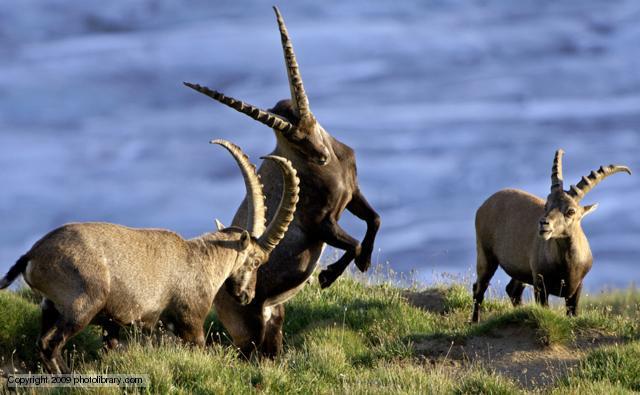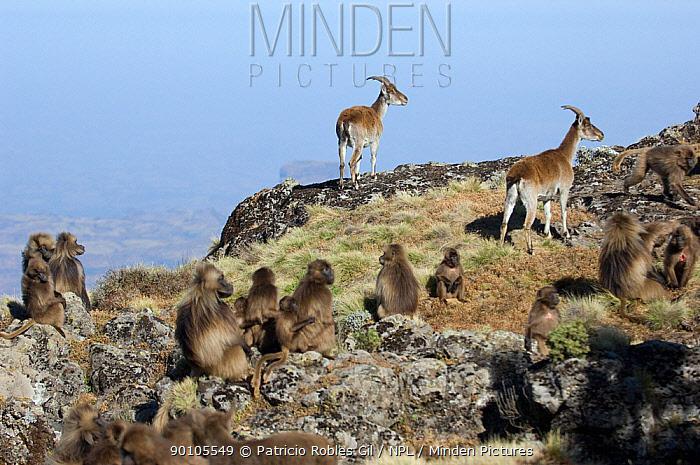The first image is the image on the left, the second image is the image on the right. Assess this claim about the two images: "A horned animal has both front legs off the ground in one image.". Correct or not? Answer yes or no. Yes. 